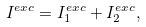<formula> <loc_0><loc_0><loc_500><loc_500>I ^ { e x c } = I ^ { e x c } _ { 1 } + I ^ { e x c } _ { 2 } ,</formula> 